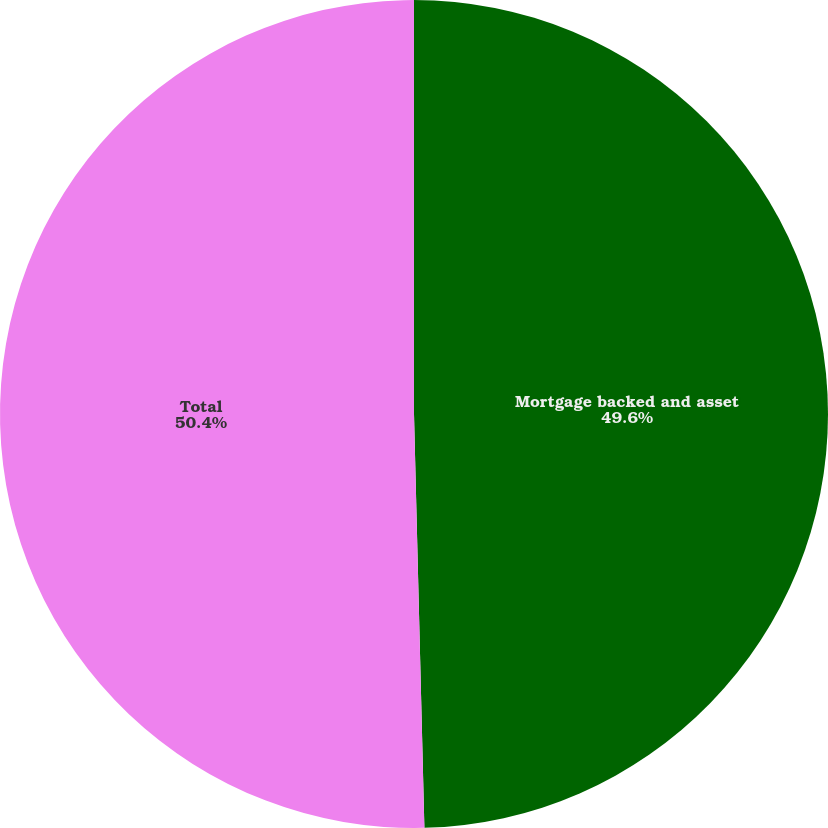<chart> <loc_0><loc_0><loc_500><loc_500><pie_chart><fcel>Mortgage backed and asset<fcel>Total<nl><fcel>49.6%<fcel>50.4%<nl></chart> 